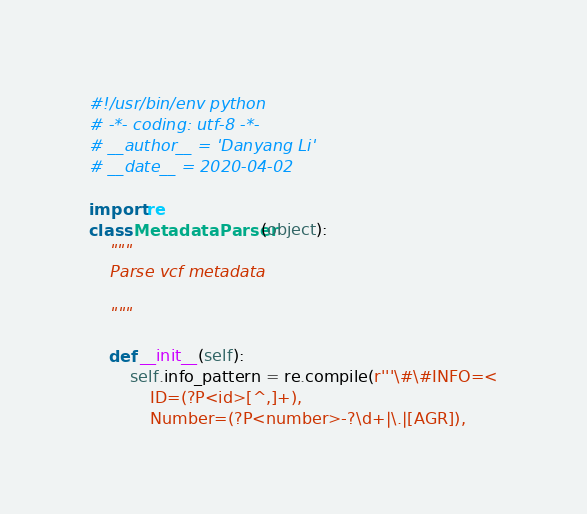<code> <loc_0><loc_0><loc_500><loc_500><_Python_>#!/usr/bin/env python
# -*- coding: utf-8 -*-
# __author__ = 'Danyang Li'
# __date__ = 2020-04-02

import re
class MetadataParser(object):
    """
    Parse vcf metadata

    """

    def __init__(self):
        self.info_pattern = re.compile(r'''\#\#INFO=<
            ID=(?P<id>[^,]+),
            Number=(?P<number>-?\d+|\.|[AGR]),</code> 